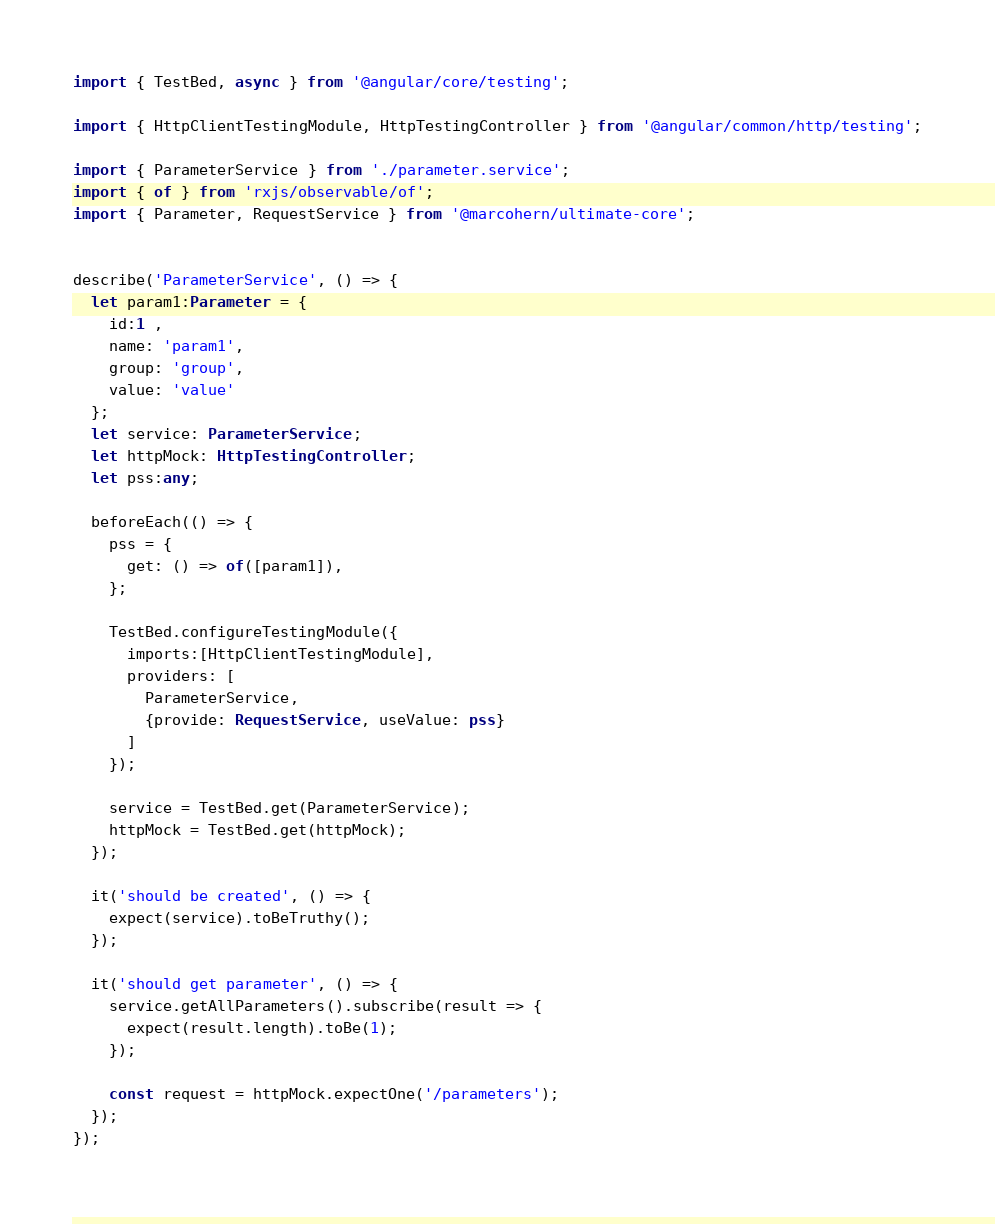<code> <loc_0><loc_0><loc_500><loc_500><_TypeScript_>import { TestBed, async } from '@angular/core/testing';

import { HttpClientTestingModule, HttpTestingController } from '@angular/common/http/testing';

import { ParameterService } from './parameter.service';
import { of } from 'rxjs/observable/of';
import { Parameter, RequestService } from '@marcohern/ultimate-core';


describe('ParameterService', () => {
  let param1:Parameter = {
    id:1 ,
    name: 'param1',
    group: 'group',
    value: 'value'
  };
  let service: ParameterService;
  let httpMock: HttpTestingController;
  let pss:any;
  
  beforeEach(() => {
    pss = {
      get: () => of([param1]),
    };

    TestBed.configureTestingModule({
      imports:[HttpClientTestingModule],
      providers: [
        ParameterService,
        {provide: RequestService, useValue: pss}
      ]
    });

    service = TestBed.get(ParameterService);
    httpMock = TestBed.get(httpMock);
  });

  it('should be created', () => {
    expect(service).toBeTruthy();
  });

  it('should get parameter', () => {
    service.getAllParameters().subscribe(result => {
      expect(result.length).toBe(1);
    });

    const request = httpMock.expectOne('/parameters');
  });
});
</code> 